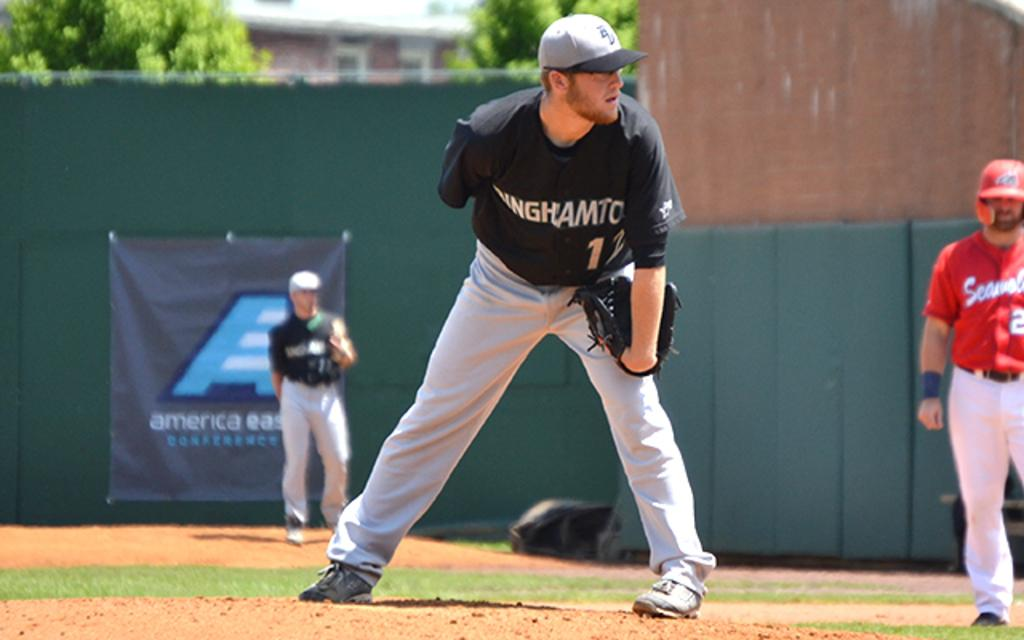Provide a one-sentence caption for the provided image. A baseball pitcher in a Binghamton uniform readies himself to throw. 